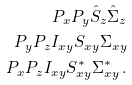<formula> <loc_0><loc_0><loc_500><loc_500>P _ { x } P _ { y } \hat { S } _ { z } \hat { \Sigma } _ { z } \\ P _ { y } P _ { z } I _ { x y } S _ { x y } \Sigma _ { x y } \\ P _ { x } P _ { z } I _ { x y } S ^ { * } _ { x y } \Sigma ^ { * } _ { x y } \, .</formula> 